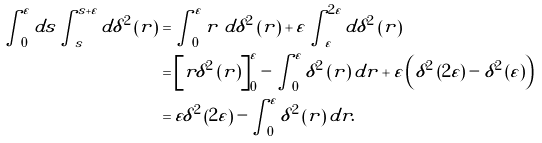<formula> <loc_0><loc_0><loc_500><loc_500>\int _ { 0 } ^ { \varepsilon } d s \int _ { s } ^ { s + \varepsilon } d \delta ^ { 2 } \left ( r \right ) & = \int _ { 0 } ^ { \varepsilon } r \ d \delta ^ { 2 } \left ( r \right ) + \varepsilon \int _ { \varepsilon } ^ { 2 \varepsilon } d \delta ^ { 2 } \left ( r \right ) \\ & = \left [ r \delta ^ { 2 } \left ( r \right ) \right ] _ { 0 } ^ { \varepsilon } - \int _ { 0 } ^ { \varepsilon } \delta ^ { 2 } \left ( r \right ) d r + \varepsilon \left ( \delta ^ { 2 } \left ( 2 \varepsilon \right ) - \delta ^ { 2 } \left ( \varepsilon \right ) \right ) \\ & = \varepsilon \delta ^ { 2 } \left ( 2 \varepsilon \right ) - \int _ { 0 } ^ { \varepsilon } \delta ^ { 2 } \left ( r \right ) d r .</formula> 